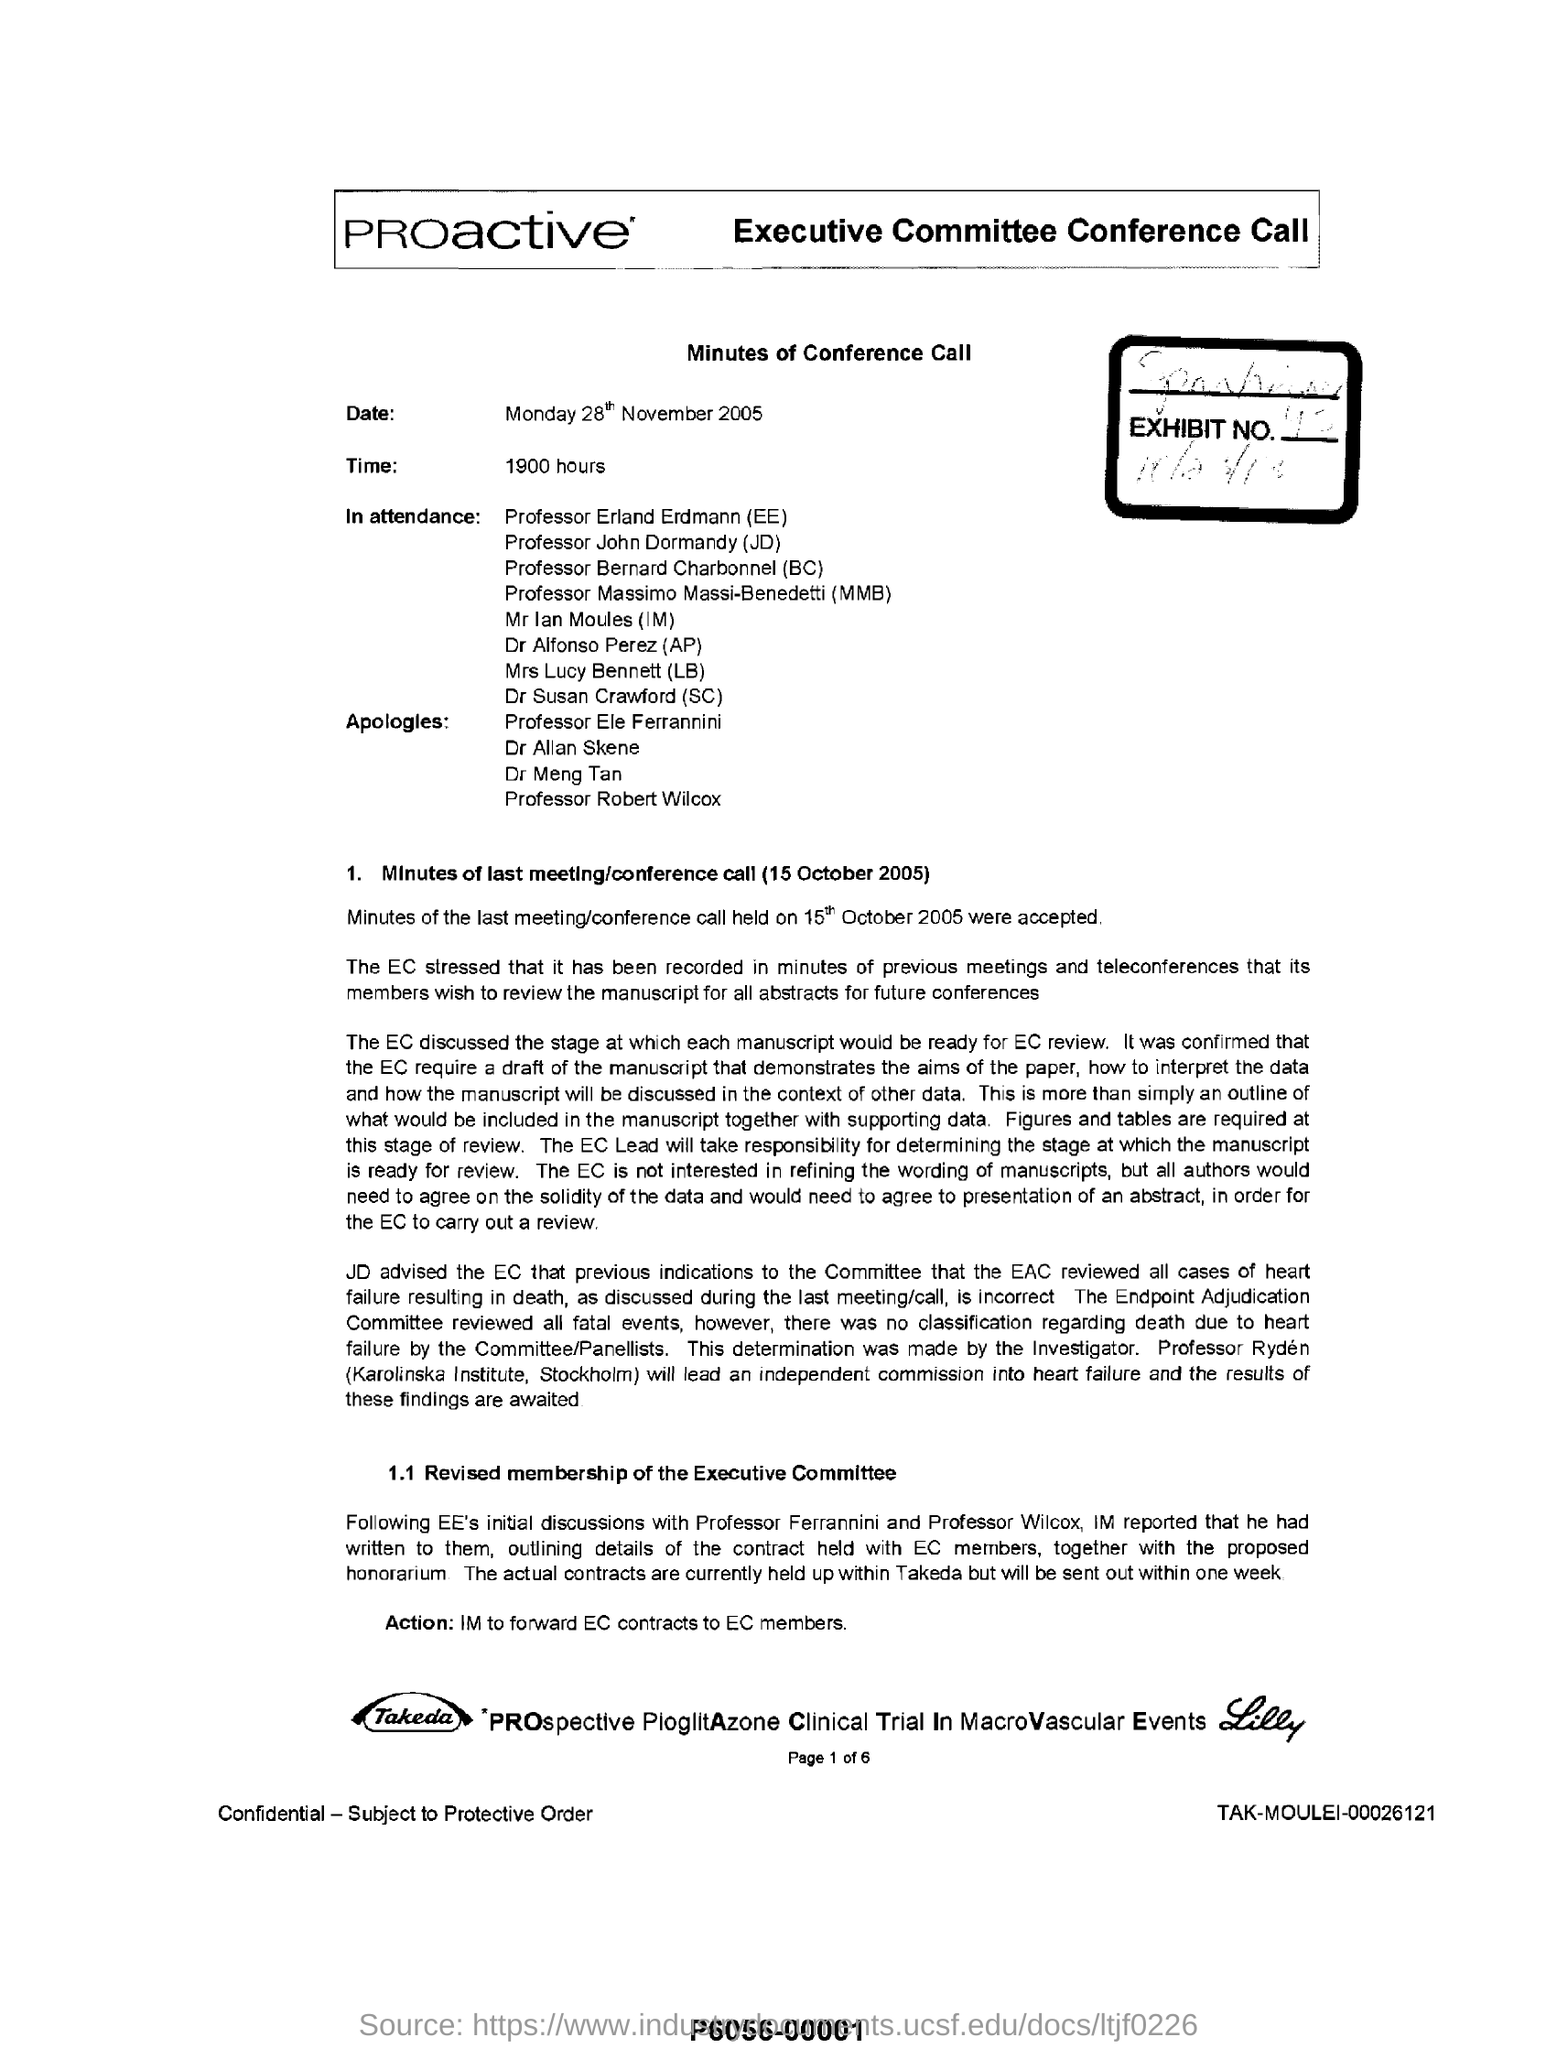Mention the first name listed in the "apologies"?
Make the answer very short. Professor Ele Ferrannini. When was  the last meeting/conference call held on ?
Provide a succinct answer. 15th October 2005. What is the date mentioned under the title - " minutes of conference call"?
Provide a succinct answer. 28th November 2005. 